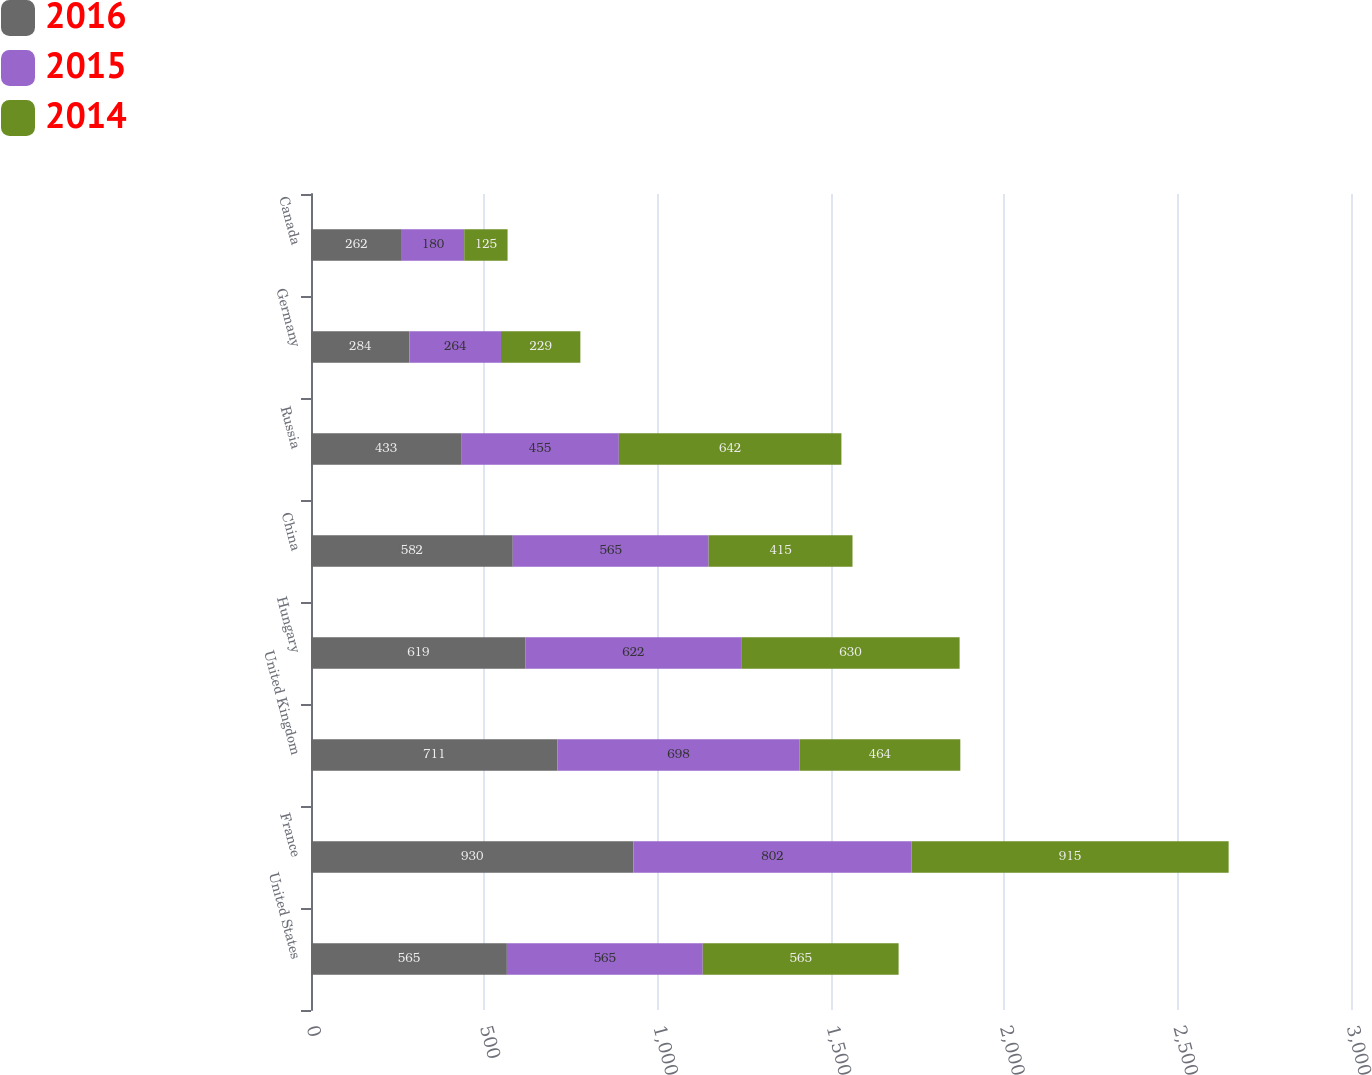Convert chart. <chart><loc_0><loc_0><loc_500><loc_500><stacked_bar_chart><ecel><fcel>United States<fcel>France<fcel>United Kingdom<fcel>Hungary<fcel>China<fcel>Russia<fcel>Germany<fcel>Canada<nl><fcel>2016<fcel>565<fcel>930<fcel>711<fcel>619<fcel>582<fcel>433<fcel>284<fcel>262<nl><fcel>2015<fcel>565<fcel>802<fcel>698<fcel>622<fcel>565<fcel>455<fcel>264<fcel>180<nl><fcel>2014<fcel>565<fcel>915<fcel>464<fcel>630<fcel>415<fcel>642<fcel>229<fcel>125<nl></chart> 